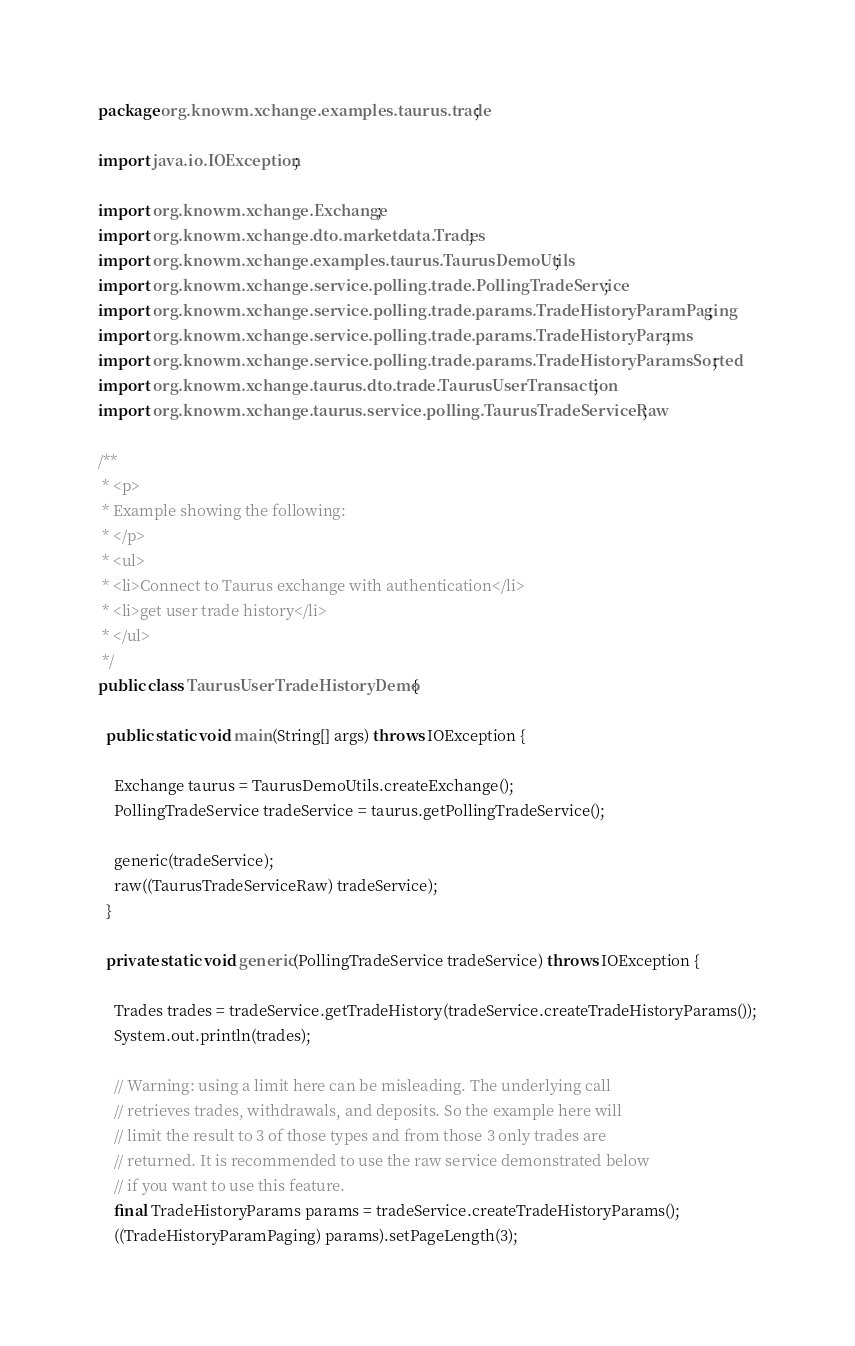Convert code to text. <code><loc_0><loc_0><loc_500><loc_500><_Java_>package org.knowm.xchange.examples.taurus.trade;

import java.io.IOException;

import org.knowm.xchange.Exchange;
import org.knowm.xchange.dto.marketdata.Trades;
import org.knowm.xchange.examples.taurus.TaurusDemoUtils;
import org.knowm.xchange.service.polling.trade.PollingTradeService;
import org.knowm.xchange.service.polling.trade.params.TradeHistoryParamPaging;
import org.knowm.xchange.service.polling.trade.params.TradeHistoryParams;
import org.knowm.xchange.service.polling.trade.params.TradeHistoryParamsSorted;
import org.knowm.xchange.taurus.dto.trade.TaurusUserTransaction;
import org.knowm.xchange.taurus.service.polling.TaurusTradeServiceRaw;

/**
 * <p>
 * Example showing the following:
 * </p>
 * <ul>
 * <li>Connect to Taurus exchange with authentication</li>
 * <li>get user trade history</li>
 * </ul>
 */
public class TaurusUserTradeHistoryDemo {

  public static void main(String[] args) throws IOException {

    Exchange taurus = TaurusDemoUtils.createExchange();
    PollingTradeService tradeService = taurus.getPollingTradeService();

    generic(tradeService);
    raw((TaurusTradeServiceRaw) tradeService);
  }

  private static void generic(PollingTradeService tradeService) throws IOException {

    Trades trades = tradeService.getTradeHistory(tradeService.createTradeHistoryParams());
    System.out.println(trades);

    // Warning: using a limit here can be misleading. The underlying call
    // retrieves trades, withdrawals, and deposits. So the example here will
    // limit the result to 3 of those types and from those 3 only trades are
    // returned. It is recommended to use the raw service demonstrated below
    // if you want to use this feature.
    final TradeHistoryParams params = tradeService.createTradeHistoryParams();
    ((TradeHistoryParamPaging) params).setPageLength(3);</code> 